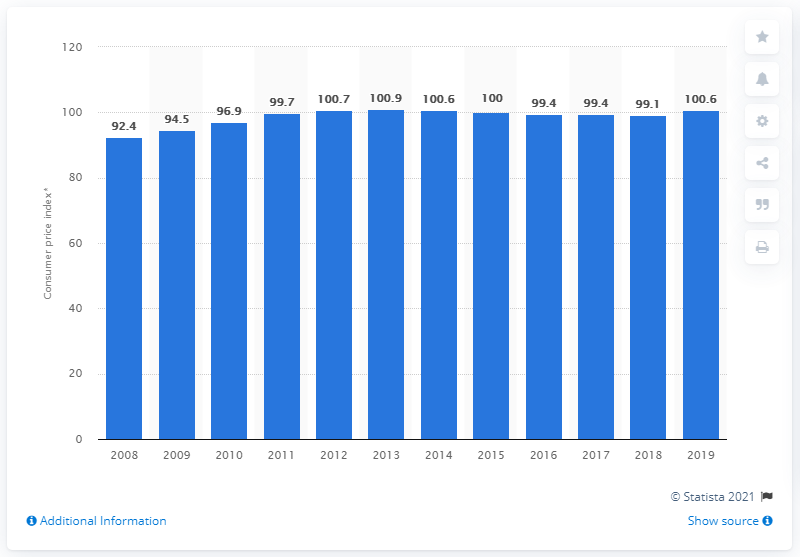Outline some significant characteristics in this image. In 2019, the price index value of personal care was 100.6. 